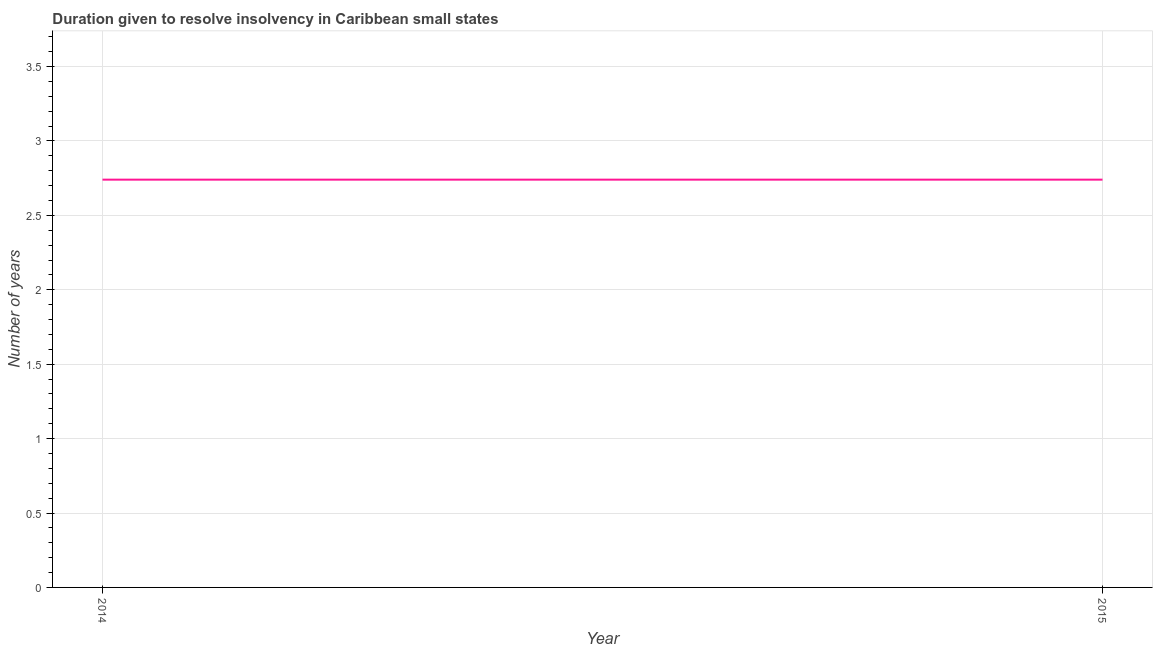What is the number of years to resolve insolvency in 2015?
Keep it short and to the point. 2.74. Across all years, what is the maximum number of years to resolve insolvency?
Your response must be concise. 2.74. Across all years, what is the minimum number of years to resolve insolvency?
Give a very brief answer. 2.74. In which year was the number of years to resolve insolvency maximum?
Your answer should be very brief. 2014. What is the sum of the number of years to resolve insolvency?
Offer a terse response. 5.48. What is the average number of years to resolve insolvency per year?
Make the answer very short. 2.74. What is the median number of years to resolve insolvency?
Ensure brevity in your answer.  2.74. In how many years, is the number of years to resolve insolvency greater than 3.6 ?
Your answer should be very brief. 0. Is the number of years to resolve insolvency in 2014 less than that in 2015?
Offer a very short reply. No. In how many years, is the number of years to resolve insolvency greater than the average number of years to resolve insolvency taken over all years?
Offer a terse response. 0. What is the difference between two consecutive major ticks on the Y-axis?
Your answer should be very brief. 0.5. Does the graph contain any zero values?
Keep it short and to the point. No. What is the title of the graph?
Your answer should be compact. Duration given to resolve insolvency in Caribbean small states. What is the label or title of the Y-axis?
Your answer should be very brief. Number of years. What is the Number of years of 2014?
Provide a succinct answer. 2.74. What is the Number of years in 2015?
Offer a terse response. 2.74. What is the ratio of the Number of years in 2014 to that in 2015?
Your answer should be very brief. 1. 